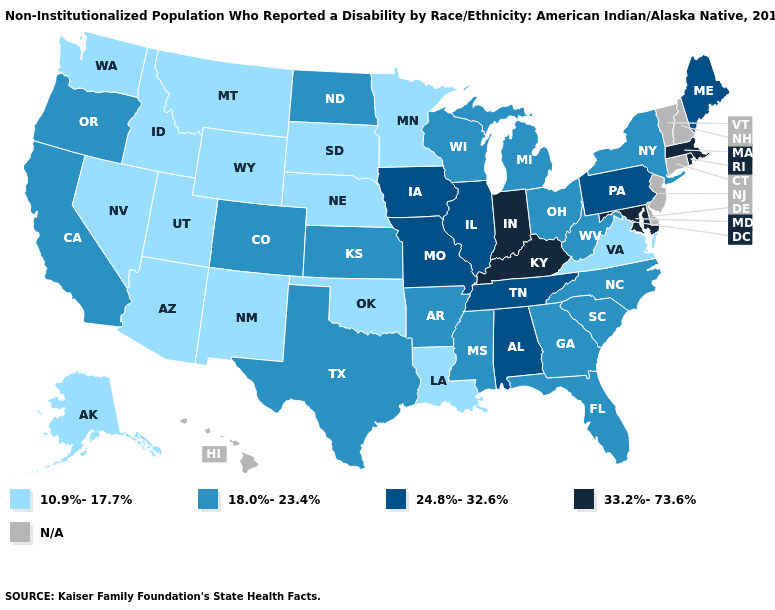Name the states that have a value in the range 24.8%-32.6%?
Give a very brief answer. Alabama, Illinois, Iowa, Maine, Missouri, Pennsylvania, Tennessee. What is the lowest value in the USA?
Give a very brief answer. 10.9%-17.7%. Name the states that have a value in the range 18.0%-23.4%?
Be succinct. Arkansas, California, Colorado, Florida, Georgia, Kansas, Michigan, Mississippi, New York, North Carolina, North Dakota, Ohio, Oregon, South Carolina, Texas, West Virginia, Wisconsin. Among the states that border New Hampshire , which have the highest value?
Quick response, please. Massachusetts. Among the states that border Florida , which have the lowest value?
Keep it brief. Georgia. What is the highest value in the Northeast ?
Keep it brief. 33.2%-73.6%. Among the states that border Vermont , which have the lowest value?
Quick response, please. New York. What is the value of California?
Keep it brief. 18.0%-23.4%. Which states hav the highest value in the MidWest?
Keep it brief. Indiana. What is the value of New Mexico?
Be succinct. 10.9%-17.7%. Name the states that have a value in the range N/A?
Short answer required. Connecticut, Delaware, Hawaii, New Hampshire, New Jersey, Vermont. Does Kentucky have the lowest value in the South?
Answer briefly. No. What is the value of Illinois?
Be succinct. 24.8%-32.6%. 